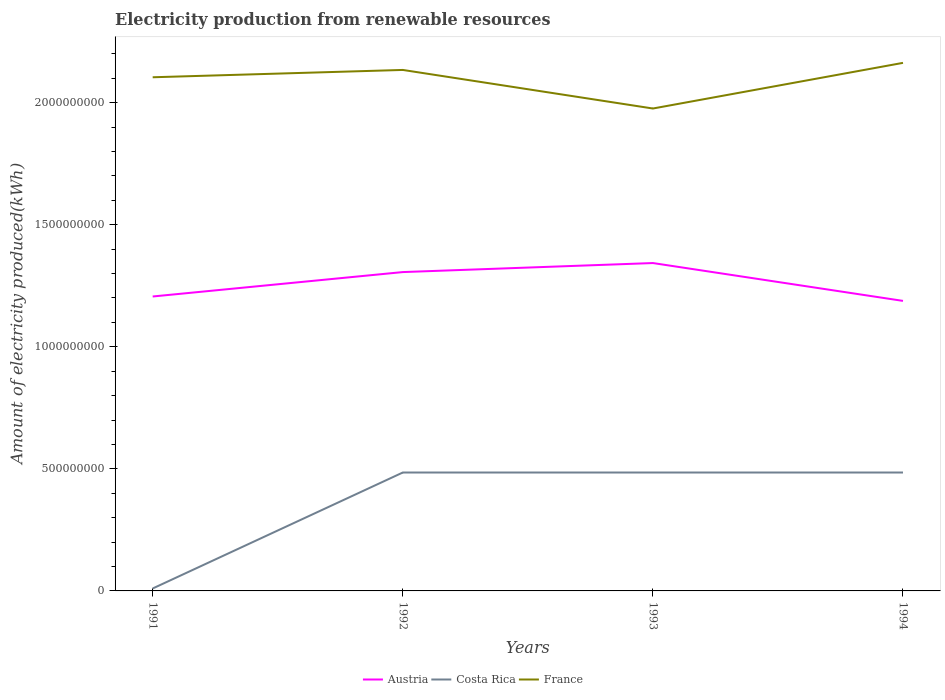How many different coloured lines are there?
Your answer should be compact. 3. In which year was the amount of electricity produced in Costa Rica maximum?
Provide a succinct answer. 1991. What is the difference between the highest and the second highest amount of electricity produced in Costa Rica?
Your response must be concise. 4.75e+08. What is the difference between the highest and the lowest amount of electricity produced in France?
Offer a terse response. 3. What is the difference between two consecutive major ticks on the Y-axis?
Provide a succinct answer. 5.00e+08. Are the values on the major ticks of Y-axis written in scientific E-notation?
Offer a terse response. No. Where does the legend appear in the graph?
Your answer should be very brief. Bottom center. What is the title of the graph?
Offer a very short reply. Electricity production from renewable resources. What is the label or title of the X-axis?
Ensure brevity in your answer.  Years. What is the label or title of the Y-axis?
Provide a succinct answer. Amount of electricity produced(kWh). What is the Amount of electricity produced(kWh) of Austria in 1991?
Offer a terse response. 1.21e+09. What is the Amount of electricity produced(kWh) in France in 1991?
Make the answer very short. 2.10e+09. What is the Amount of electricity produced(kWh) in Austria in 1992?
Your answer should be very brief. 1.31e+09. What is the Amount of electricity produced(kWh) of Costa Rica in 1992?
Offer a terse response. 4.85e+08. What is the Amount of electricity produced(kWh) of France in 1992?
Your response must be concise. 2.13e+09. What is the Amount of electricity produced(kWh) in Austria in 1993?
Your response must be concise. 1.34e+09. What is the Amount of electricity produced(kWh) in Costa Rica in 1993?
Give a very brief answer. 4.85e+08. What is the Amount of electricity produced(kWh) in France in 1993?
Provide a succinct answer. 1.98e+09. What is the Amount of electricity produced(kWh) of Austria in 1994?
Offer a very short reply. 1.19e+09. What is the Amount of electricity produced(kWh) in Costa Rica in 1994?
Provide a succinct answer. 4.85e+08. What is the Amount of electricity produced(kWh) in France in 1994?
Give a very brief answer. 2.16e+09. Across all years, what is the maximum Amount of electricity produced(kWh) in Austria?
Give a very brief answer. 1.34e+09. Across all years, what is the maximum Amount of electricity produced(kWh) in Costa Rica?
Your answer should be compact. 4.85e+08. Across all years, what is the maximum Amount of electricity produced(kWh) in France?
Give a very brief answer. 2.16e+09. Across all years, what is the minimum Amount of electricity produced(kWh) in Austria?
Provide a succinct answer. 1.19e+09. Across all years, what is the minimum Amount of electricity produced(kWh) in France?
Your response must be concise. 1.98e+09. What is the total Amount of electricity produced(kWh) of Austria in the graph?
Ensure brevity in your answer.  5.04e+09. What is the total Amount of electricity produced(kWh) of Costa Rica in the graph?
Your response must be concise. 1.46e+09. What is the total Amount of electricity produced(kWh) of France in the graph?
Provide a succinct answer. 8.38e+09. What is the difference between the Amount of electricity produced(kWh) in Austria in 1991 and that in 1992?
Give a very brief answer. -1.00e+08. What is the difference between the Amount of electricity produced(kWh) of Costa Rica in 1991 and that in 1992?
Provide a succinct answer. -4.75e+08. What is the difference between the Amount of electricity produced(kWh) of France in 1991 and that in 1992?
Keep it short and to the point. -3.00e+07. What is the difference between the Amount of electricity produced(kWh) in Austria in 1991 and that in 1993?
Offer a terse response. -1.37e+08. What is the difference between the Amount of electricity produced(kWh) in Costa Rica in 1991 and that in 1993?
Offer a very short reply. -4.75e+08. What is the difference between the Amount of electricity produced(kWh) of France in 1991 and that in 1993?
Offer a terse response. 1.28e+08. What is the difference between the Amount of electricity produced(kWh) of Austria in 1991 and that in 1994?
Provide a succinct answer. 1.80e+07. What is the difference between the Amount of electricity produced(kWh) of Costa Rica in 1991 and that in 1994?
Provide a succinct answer. -4.75e+08. What is the difference between the Amount of electricity produced(kWh) in France in 1991 and that in 1994?
Make the answer very short. -5.90e+07. What is the difference between the Amount of electricity produced(kWh) in Austria in 1992 and that in 1993?
Provide a succinct answer. -3.70e+07. What is the difference between the Amount of electricity produced(kWh) of Costa Rica in 1992 and that in 1993?
Make the answer very short. 0. What is the difference between the Amount of electricity produced(kWh) of France in 1992 and that in 1993?
Keep it short and to the point. 1.58e+08. What is the difference between the Amount of electricity produced(kWh) in Austria in 1992 and that in 1994?
Your answer should be compact. 1.18e+08. What is the difference between the Amount of electricity produced(kWh) in Costa Rica in 1992 and that in 1994?
Your response must be concise. 0. What is the difference between the Amount of electricity produced(kWh) in France in 1992 and that in 1994?
Make the answer very short. -2.90e+07. What is the difference between the Amount of electricity produced(kWh) in Austria in 1993 and that in 1994?
Ensure brevity in your answer.  1.55e+08. What is the difference between the Amount of electricity produced(kWh) in Costa Rica in 1993 and that in 1994?
Offer a very short reply. 0. What is the difference between the Amount of electricity produced(kWh) in France in 1993 and that in 1994?
Offer a terse response. -1.87e+08. What is the difference between the Amount of electricity produced(kWh) of Austria in 1991 and the Amount of electricity produced(kWh) of Costa Rica in 1992?
Keep it short and to the point. 7.21e+08. What is the difference between the Amount of electricity produced(kWh) in Austria in 1991 and the Amount of electricity produced(kWh) in France in 1992?
Provide a short and direct response. -9.28e+08. What is the difference between the Amount of electricity produced(kWh) in Costa Rica in 1991 and the Amount of electricity produced(kWh) in France in 1992?
Provide a succinct answer. -2.12e+09. What is the difference between the Amount of electricity produced(kWh) in Austria in 1991 and the Amount of electricity produced(kWh) in Costa Rica in 1993?
Offer a very short reply. 7.21e+08. What is the difference between the Amount of electricity produced(kWh) in Austria in 1991 and the Amount of electricity produced(kWh) in France in 1993?
Ensure brevity in your answer.  -7.70e+08. What is the difference between the Amount of electricity produced(kWh) of Costa Rica in 1991 and the Amount of electricity produced(kWh) of France in 1993?
Offer a very short reply. -1.97e+09. What is the difference between the Amount of electricity produced(kWh) in Austria in 1991 and the Amount of electricity produced(kWh) in Costa Rica in 1994?
Your response must be concise. 7.21e+08. What is the difference between the Amount of electricity produced(kWh) of Austria in 1991 and the Amount of electricity produced(kWh) of France in 1994?
Your response must be concise. -9.57e+08. What is the difference between the Amount of electricity produced(kWh) in Costa Rica in 1991 and the Amount of electricity produced(kWh) in France in 1994?
Your answer should be very brief. -2.15e+09. What is the difference between the Amount of electricity produced(kWh) in Austria in 1992 and the Amount of electricity produced(kWh) in Costa Rica in 1993?
Keep it short and to the point. 8.21e+08. What is the difference between the Amount of electricity produced(kWh) of Austria in 1992 and the Amount of electricity produced(kWh) of France in 1993?
Give a very brief answer. -6.70e+08. What is the difference between the Amount of electricity produced(kWh) in Costa Rica in 1992 and the Amount of electricity produced(kWh) in France in 1993?
Your answer should be very brief. -1.49e+09. What is the difference between the Amount of electricity produced(kWh) of Austria in 1992 and the Amount of electricity produced(kWh) of Costa Rica in 1994?
Provide a succinct answer. 8.21e+08. What is the difference between the Amount of electricity produced(kWh) in Austria in 1992 and the Amount of electricity produced(kWh) in France in 1994?
Ensure brevity in your answer.  -8.57e+08. What is the difference between the Amount of electricity produced(kWh) in Costa Rica in 1992 and the Amount of electricity produced(kWh) in France in 1994?
Your answer should be compact. -1.68e+09. What is the difference between the Amount of electricity produced(kWh) in Austria in 1993 and the Amount of electricity produced(kWh) in Costa Rica in 1994?
Offer a terse response. 8.58e+08. What is the difference between the Amount of electricity produced(kWh) of Austria in 1993 and the Amount of electricity produced(kWh) of France in 1994?
Provide a succinct answer. -8.20e+08. What is the difference between the Amount of electricity produced(kWh) in Costa Rica in 1993 and the Amount of electricity produced(kWh) in France in 1994?
Your answer should be compact. -1.68e+09. What is the average Amount of electricity produced(kWh) of Austria per year?
Offer a very short reply. 1.26e+09. What is the average Amount of electricity produced(kWh) in Costa Rica per year?
Offer a very short reply. 3.66e+08. What is the average Amount of electricity produced(kWh) of France per year?
Provide a succinct answer. 2.09e+09. In the year 1991, what is the difference between the Amount of electricity produced(kWh) in Austria and Amount of electricity produced(kWh) in Costa Rica?
Provide a succinct answer. 1.20e+09. In the year 1991, what is the difference between the Amount of electricity produced(kWh) in Austria and Amount of electricity produced(kWh) in France?
Your answer should be very brief. -8.98e+08. In the year 1991, what is the difference between the Amount of electricity produced(kWh) of Costa Rica and Amount of electricity produced(kWh) of France?
Ensure brevity in your answer.  -2.09e+09. In the year 1992, what is the difference between the Amount of electricity produced(kWh) in Austria and Amount of electricity produced(kWh) in Costa Rica?
Give a very brief answer. 8.21e+08. In the year 1992, what is the difference between the Amount of electricity produced(kWh) in Austria and Amount of electricity produced(kWh) in France?
Your response must be concise. -8.28e+08. In the year 1992, what is the difference between the Amount of electricity produced(kWh) of Costa Rica and Amount of electricity produced(kWh) of France?
Offer a very short reply. -1.65e+09. In the year 1993, what is the difference between the Amount of electricity produced(kWh) in Austria and Amount of electricity produced(kWh) in Costa Rica?
Provide a short and direct response. 8.58e+08. In the year 1993, what is the difference between the Amount of electricity produced(kWh) of Austria and Amount of electricity produced(kWh) of France?
Your answer should be compact. -6.33e+08. In the year 1993, what is the difference between the Amount of electricity produced(kWh) in Costa Rica and Amount of electricity produced(kWh) in France?
Your answer should be compact. -1.49e+09. In the year 1994, what is the difference between the Amount of electricity produced(kWh) of Austria and Amount of electricity produced(kWh) of Costa Rica?
Ensure brevity in your answer.  7.03e+08. In the year 1994, what is the difference between the Amount of electricity produced(kWh) in Austria and Amount of electricity produced(kWh) in France?
Your response must be concise. -9.75e+08. In the year 1994, what is the difference between the Amount of electricity produced(kWh) in Costa Rica and Amount of electricity produced(kWh) in France?
Give a very brief answer. -1.68e+09. What is the ratio of the Amount of electricity produced(kWh) in Austria in 1991 to that in 1992?
Ensure brevity in your answer.  0.92. What is the ratio of the Amount of electricity produced(kWh) of Costa Rica in 1991 to that in 1992?
Make the answer very short. 0.02. What is the ratio of the Amount of electricity produced(kWh) of France in 1991 to that in 1992?
Provide a short and direct response. 0.99. What is the ratio of the Amount of electricity produced(kWh) in Austria in 1991 to that in 1993?
Provide a short and direct response. 0.9. What is the ratio of the Amount of electricity produced(kWh) in Costa Rica in 1991 to that in 1993?
Your response must be concise. 0.02. What is the ratio of the Amount of electricity produced(kWh) in France in 1991 to that in 1993?
Give a very brief answer. 1.06. What is the ratio of the Amount of electricity produced(kWh) in Austria in 1991 to that in 1994?
Give a very brief answer. 1.02. What is the ratio of the Amount of electricity produced(kWh) in Costa Rica in 1991 to that in 1994?
Offer a very short reply. 0.02. What is the ratio of the Amount of electricity produced(kWh) of France in 1991 to that in 1994?
Ensure brevity in your answer.  0.97. What is the ratio of the Amount of electricity produced(kWh) of Austria in 1992 to that in 1993?
Make the answer very short. 0.97. What is the ratio of the Amount of electricity produced(kWh) in Costa Rica in 1992 to that in 1993?
Keep it short and to the point. 1. What is the ratio of the Amount of electricity produced(kWh) in Austria in 1992 to that in 1994?
Provide a short and direct response. 1.1. What is the ratio of the Amount of electricity produced(kWh) of Costa Rica in 1992 to that in 1994?
Ensure brevity in your answer.  1. What is the ratio of the Amount of electricity produced(kWh) in France in 1992 to that in 1994?
Provide a succinct answer. 0.99. What is the ratio of the Amount of electricity produced(kWh) of Austria in 1993 to that in 1994?
Provide a short and direct response. 1.13. What is the ratio of the Amount of electricity produced(kWh) of France in 1993 to that in 1994?
Ensure brevity in your answer.  0.91. What is the difference between the highest and the second highest Amount of electricity produced(kWh) of Austria?
Your answer should be compact. 3.70e+07. What is the difference between the highest and the second highest Amount of electricity produced(kWh) in France?
Ensure brevity in your answer.  2.90e+07. What is the difference between the highest and the lowest Amount of electricity produced(kWh) in Austria?
Ensure brevity in your answer.  1.55e+08. What is the difference between the highest and the lowest Amount of electricity produced(kWh) in Costa Rica?
Keep it short and to the point. 4.75e+08. What is the difference between the highest and the lowest Amount of electricity produced(kWh) of France?
Give a very brief answer. 1.87e+08. 